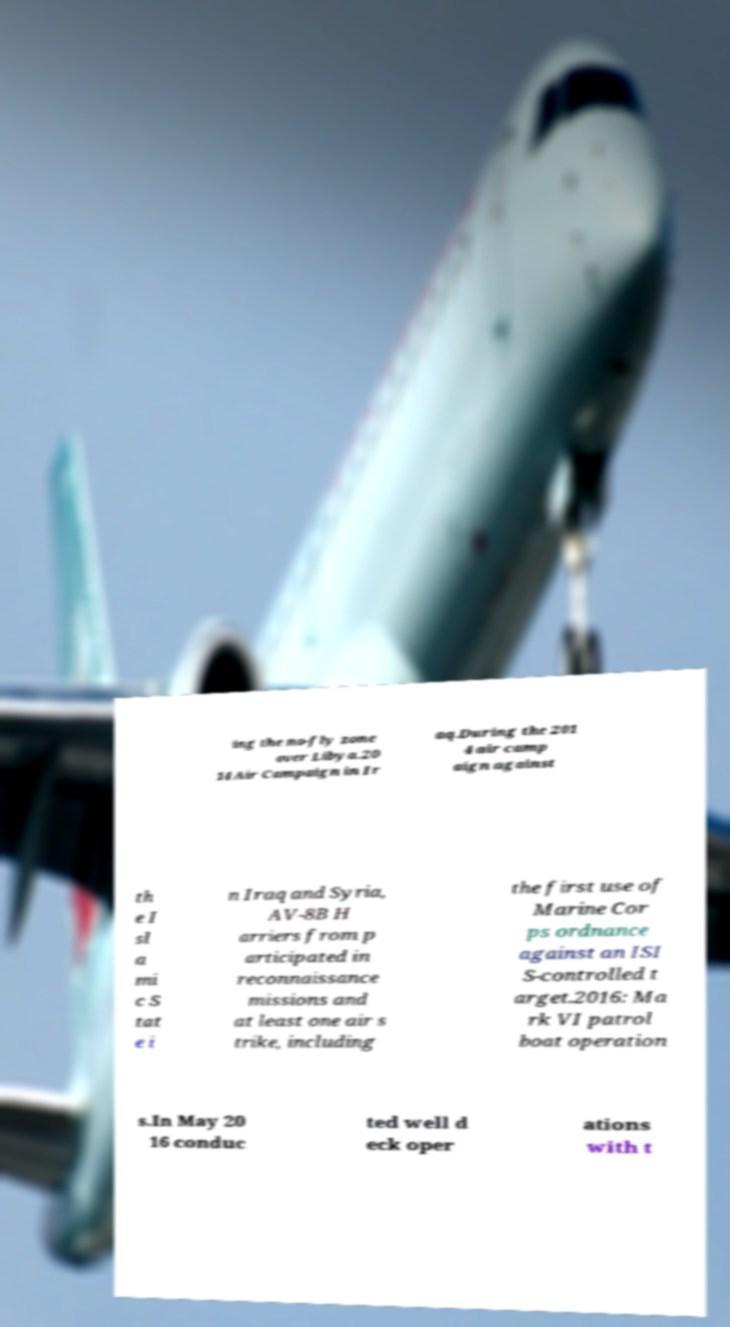Please identify and transcribe the text found in this image. ing the no-fly zone over Libya.20 14 Air Campaign in Ir aq.During the 201 4 air camp aign against th e I sl a mi c S tat e i n Iraq and Syria, AV-8B H arriers from p articipated in reconnaissance missions and at least one air s trike, including the first use of Marine Cor ps ordnance against an ISI S-controlled t arget.2016: Ma rk VI patrol boat operation s.In May 20 16 conduc ted well d eck oper ations with t 